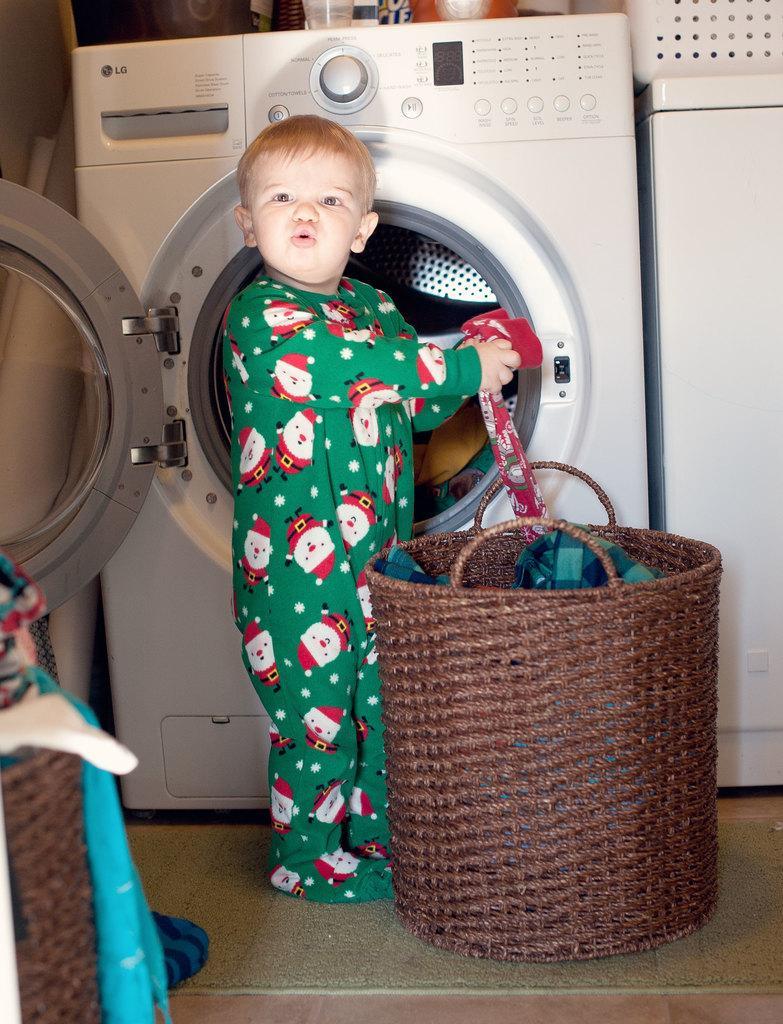How would you summarize this image in a sentence or two? In this image I can see a person standing and the person is wearing green color dress and holding few clothes. In front I can see a basket in brown color, background I can see a washing machine which is in white color. 